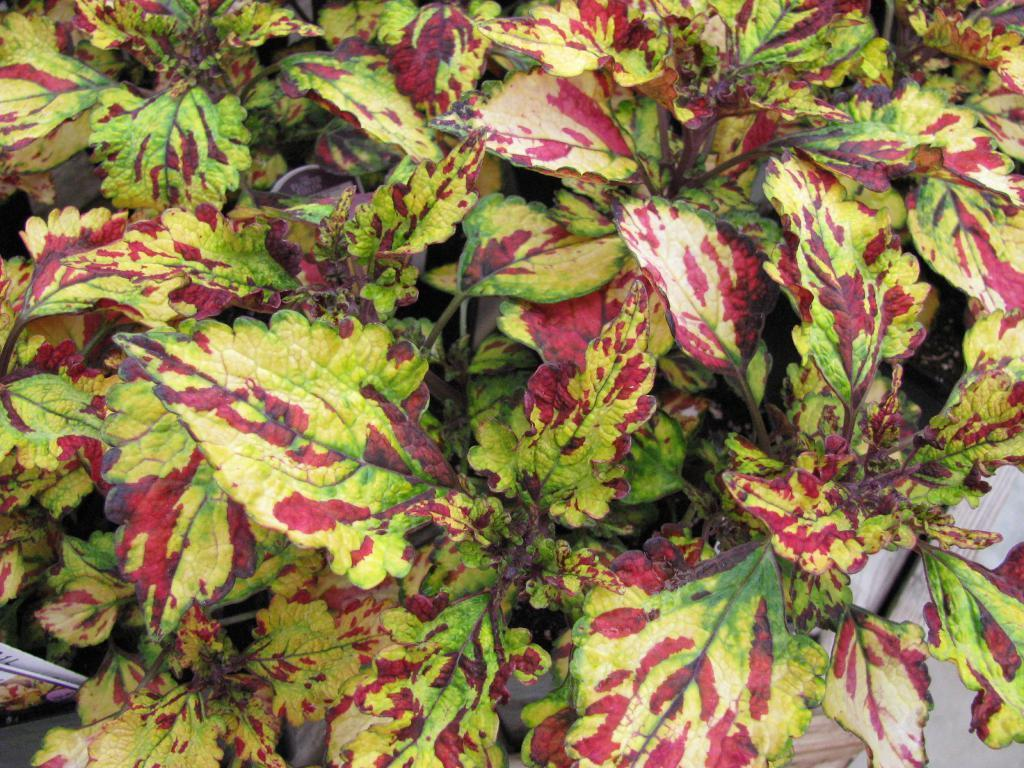What is located in the foreground of the image? There is a plant in the foreground of the image. What can be seen in the background of the image? There is a floor visible in the background of the image. How many spoons are hanging from the plant in the image? There are no spoons present in the image, as it features a plant in the foreground and a floor in the background. 